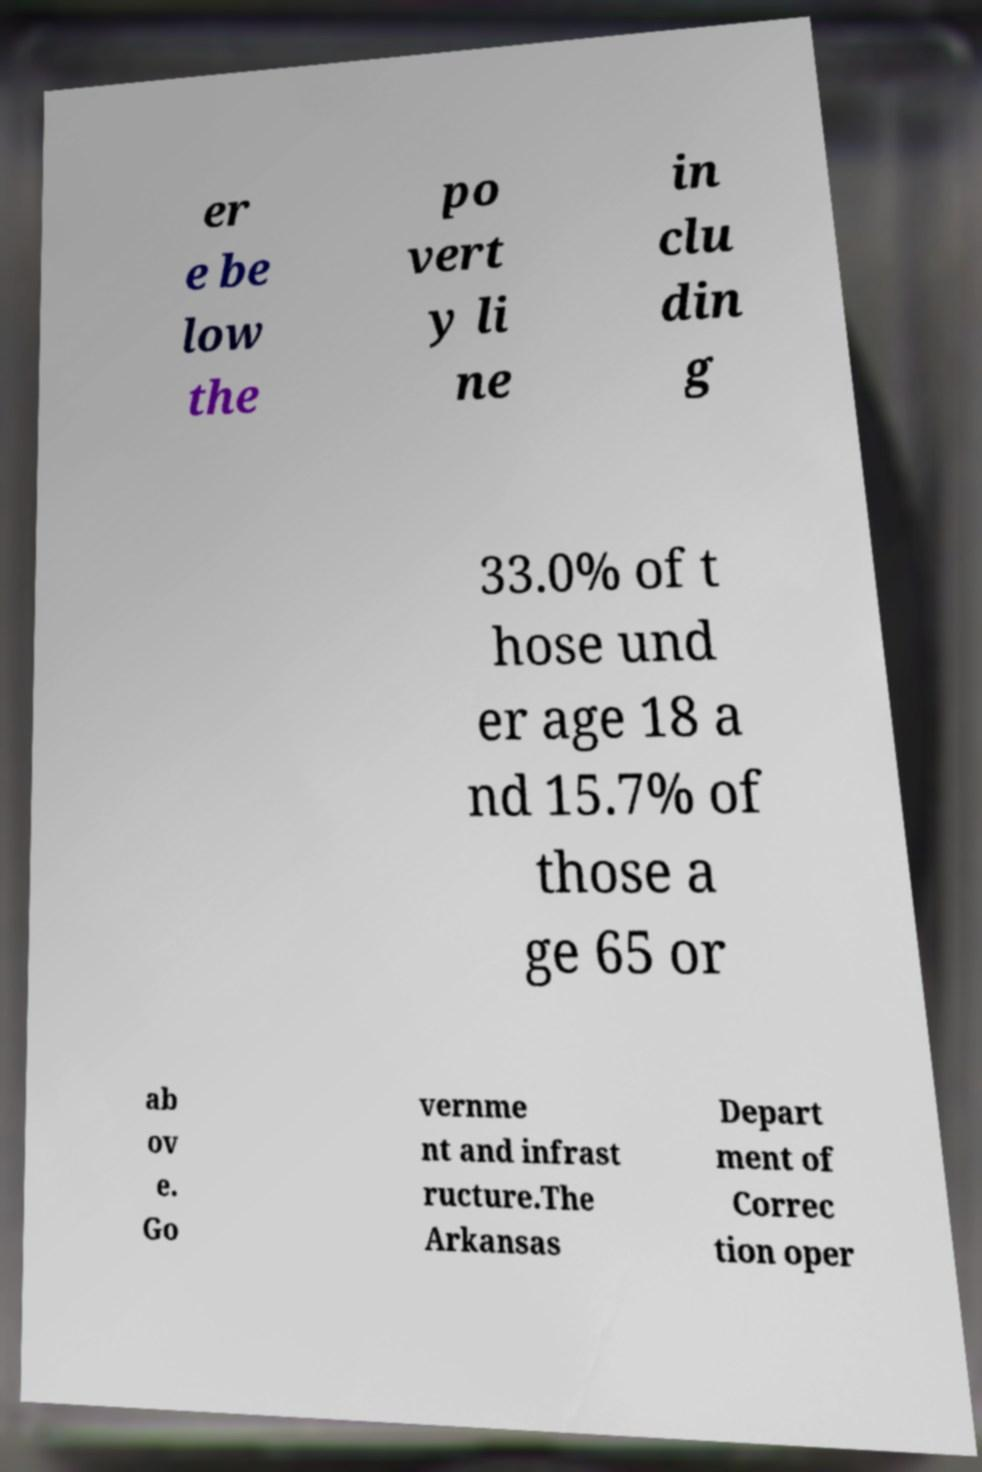For documentation purposes, I need the text within this image transcribed. Could you provide that? er e be low the po vert y li ne in clu din g 33.0% of t hose und er age 18 a nd 15.7% of those a ge 65 or ab ov e. Go vernme nt and infrast ructure.The Arkansas Depart ment of Correc tion oper 